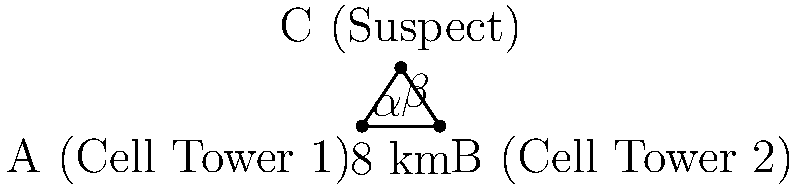In a cybercrime investigation, two cell towers are used to triangulate the location of a suspect. The towers are 8 km apart, and the angles from each tower to the suspect's location are measured. From Cell Tower 1, the angle ($\alpha$) to the suspect is 56.3°, and from Cell Tower 2, the angle ($\beta$) to the suspect is 48.2°. How far is the suspect from Cell Tower 1? To solve this problem, we'll use the law of sines. Let's follow these steps:

1) First, we need to find the third angle of the triangle. We know that the sum of angles in a triangle is 180°.
   $180° - (56.3° + 48.2°) = 75.5°$

2) Now we can use the law of sines:
   $\frac{a}{\sin A} = \frac{b}{\sin B} = \frac{c}{\sin C}$

   Where 'a' is the distance we're looking for, 'A' is the angle opposite to 'a' (75.5°), 'b' is the known distance between towers (8 km), and 'B' is the angle opposite to 'b' (56.3°).

3) We can set up the equation:
   $\frac{a}{\sin 75.5°} = \frac{8}{\sin 56.3°}$

4) Cross multiply:
   $a \cdot \sin 56.3° = 8 \cdot \sin 75.5°$

5) Solve for 'a':
   $a = \frac{8 \cdot \sin 75.5°}{\sin 56.3°}$

6) Calculate:
   $a \approx 9.14$ km

Therefore, the suspect is approximately 9.14 km from Cell Tower 1.
Answer: 9.14 km 